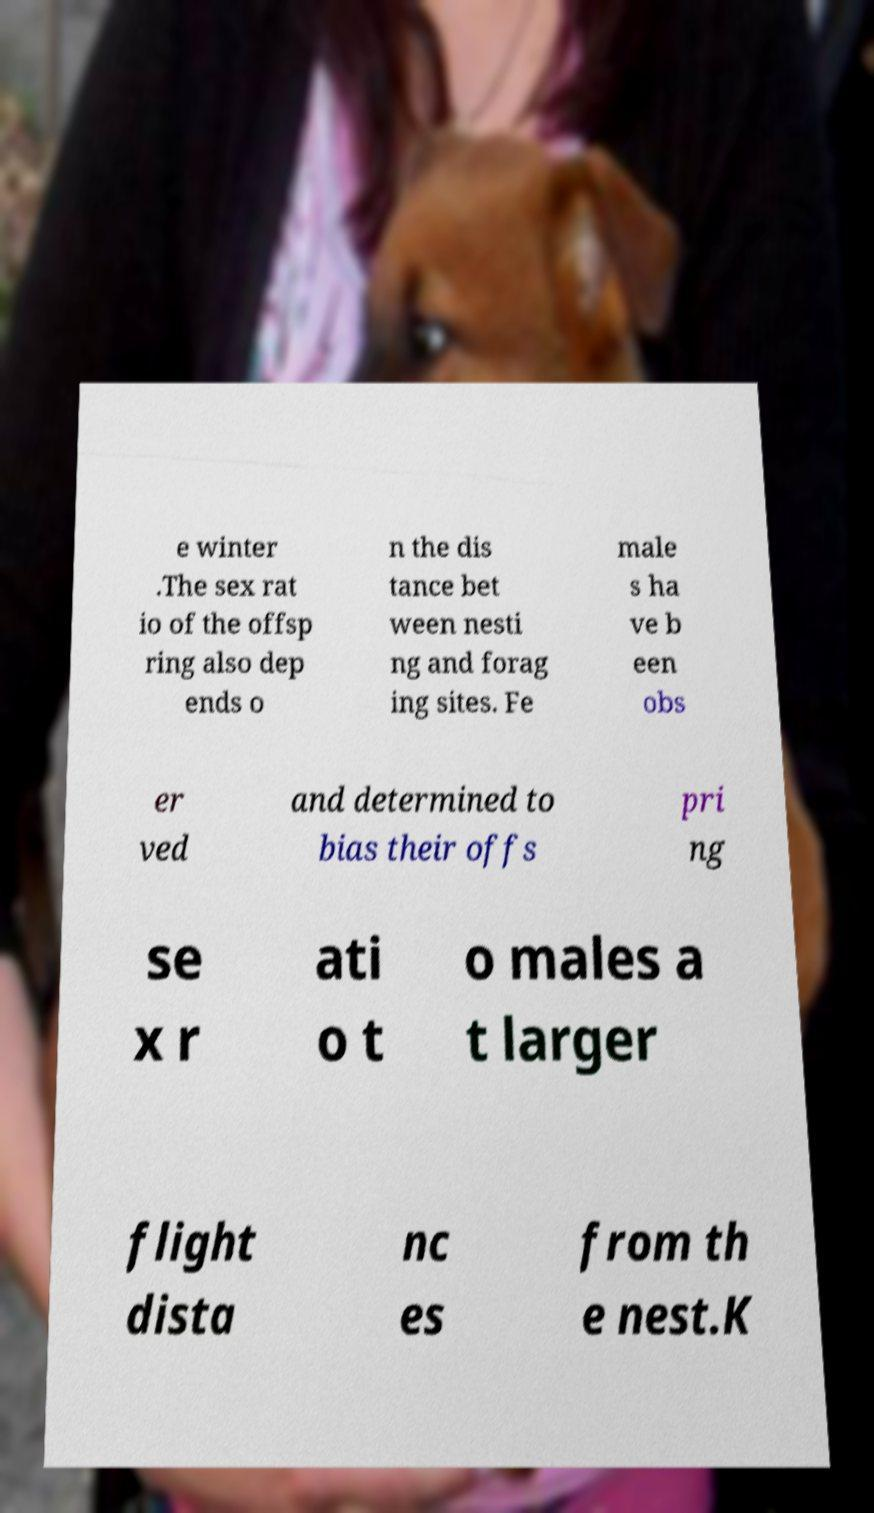I need the written content from this picture converted into text. Can you do that? e winter .The sex rat io of the offsp ring also dep ends o n the dis tance bet ween nesti ng and forag ing sites. Fe male s ha ve b een obs er ved and determined to bias their offs pri ng se x r ati o t o males a t larger flight dista nc es from th e nest.K 